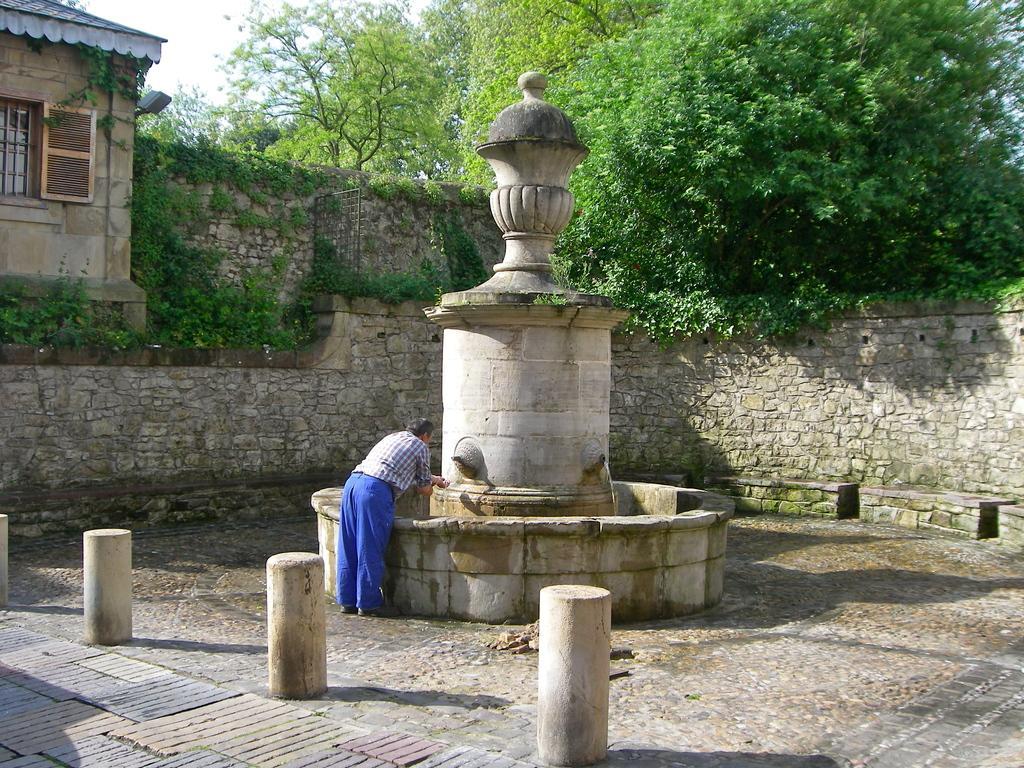Please provide a concise description of this image. In the picture I can see a man is standing on the ground. Here I can see the water, poles, plants, trees, a house and a wall. In the background I can see the sky. 